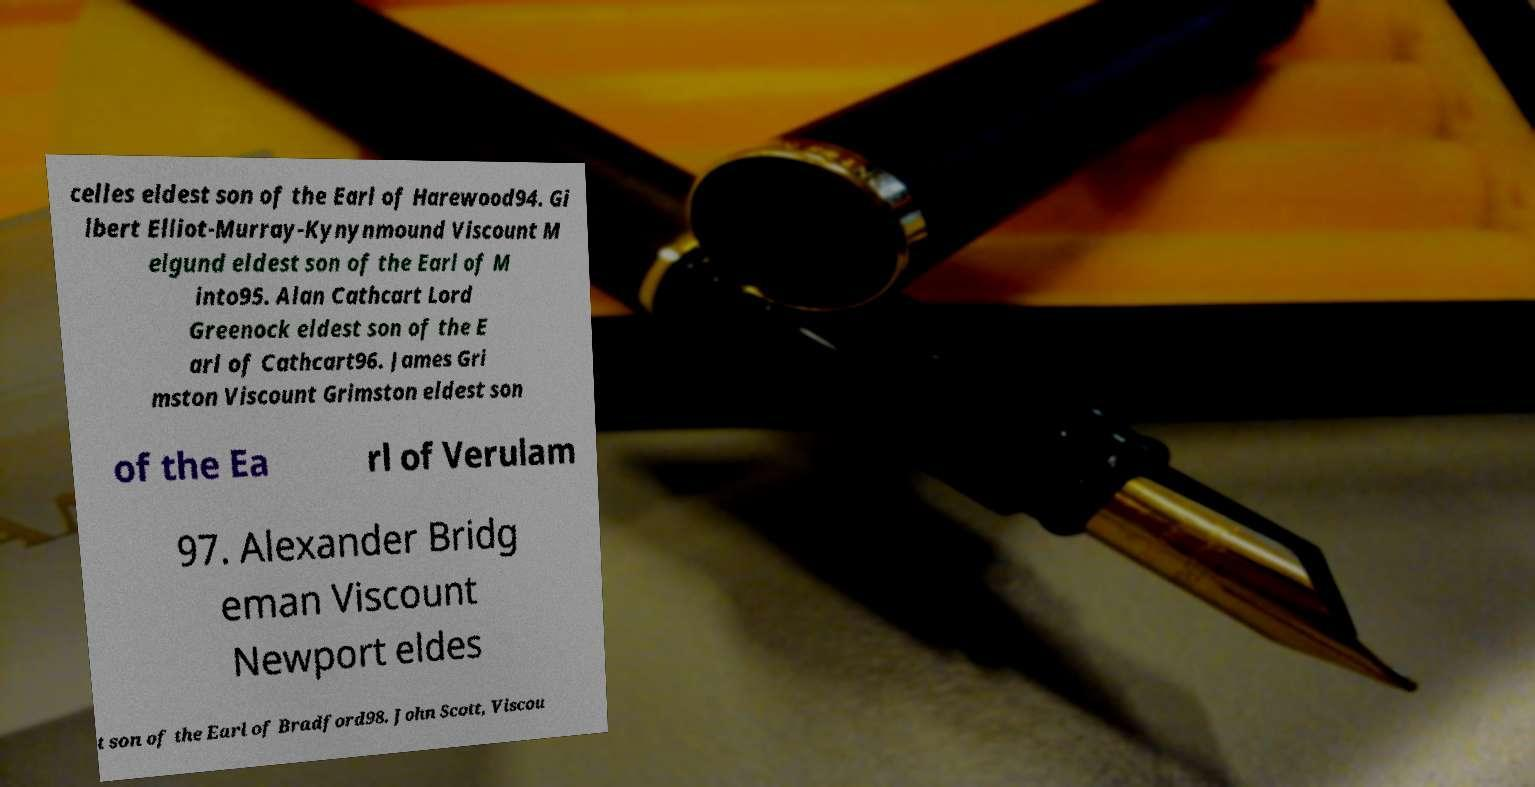What messages or text are displayed in this image? I need them in a readable, typed format. celles eldest son of the Earl of Harewood94. Gi lbert Elliot-Murray-Kynynmound Viscount M elgund eldest son of the Earl of M into95. Alan Cathcart Lord Greenock eldest son of the E arl of Cathcart96. James Gri mston Viscount Grimston eldest son of the Ea rl of Verulam 97. Alexander Bridg eman Viscount Newport eldes t son of the Earl of Bradford98. John Scott, Viscou 